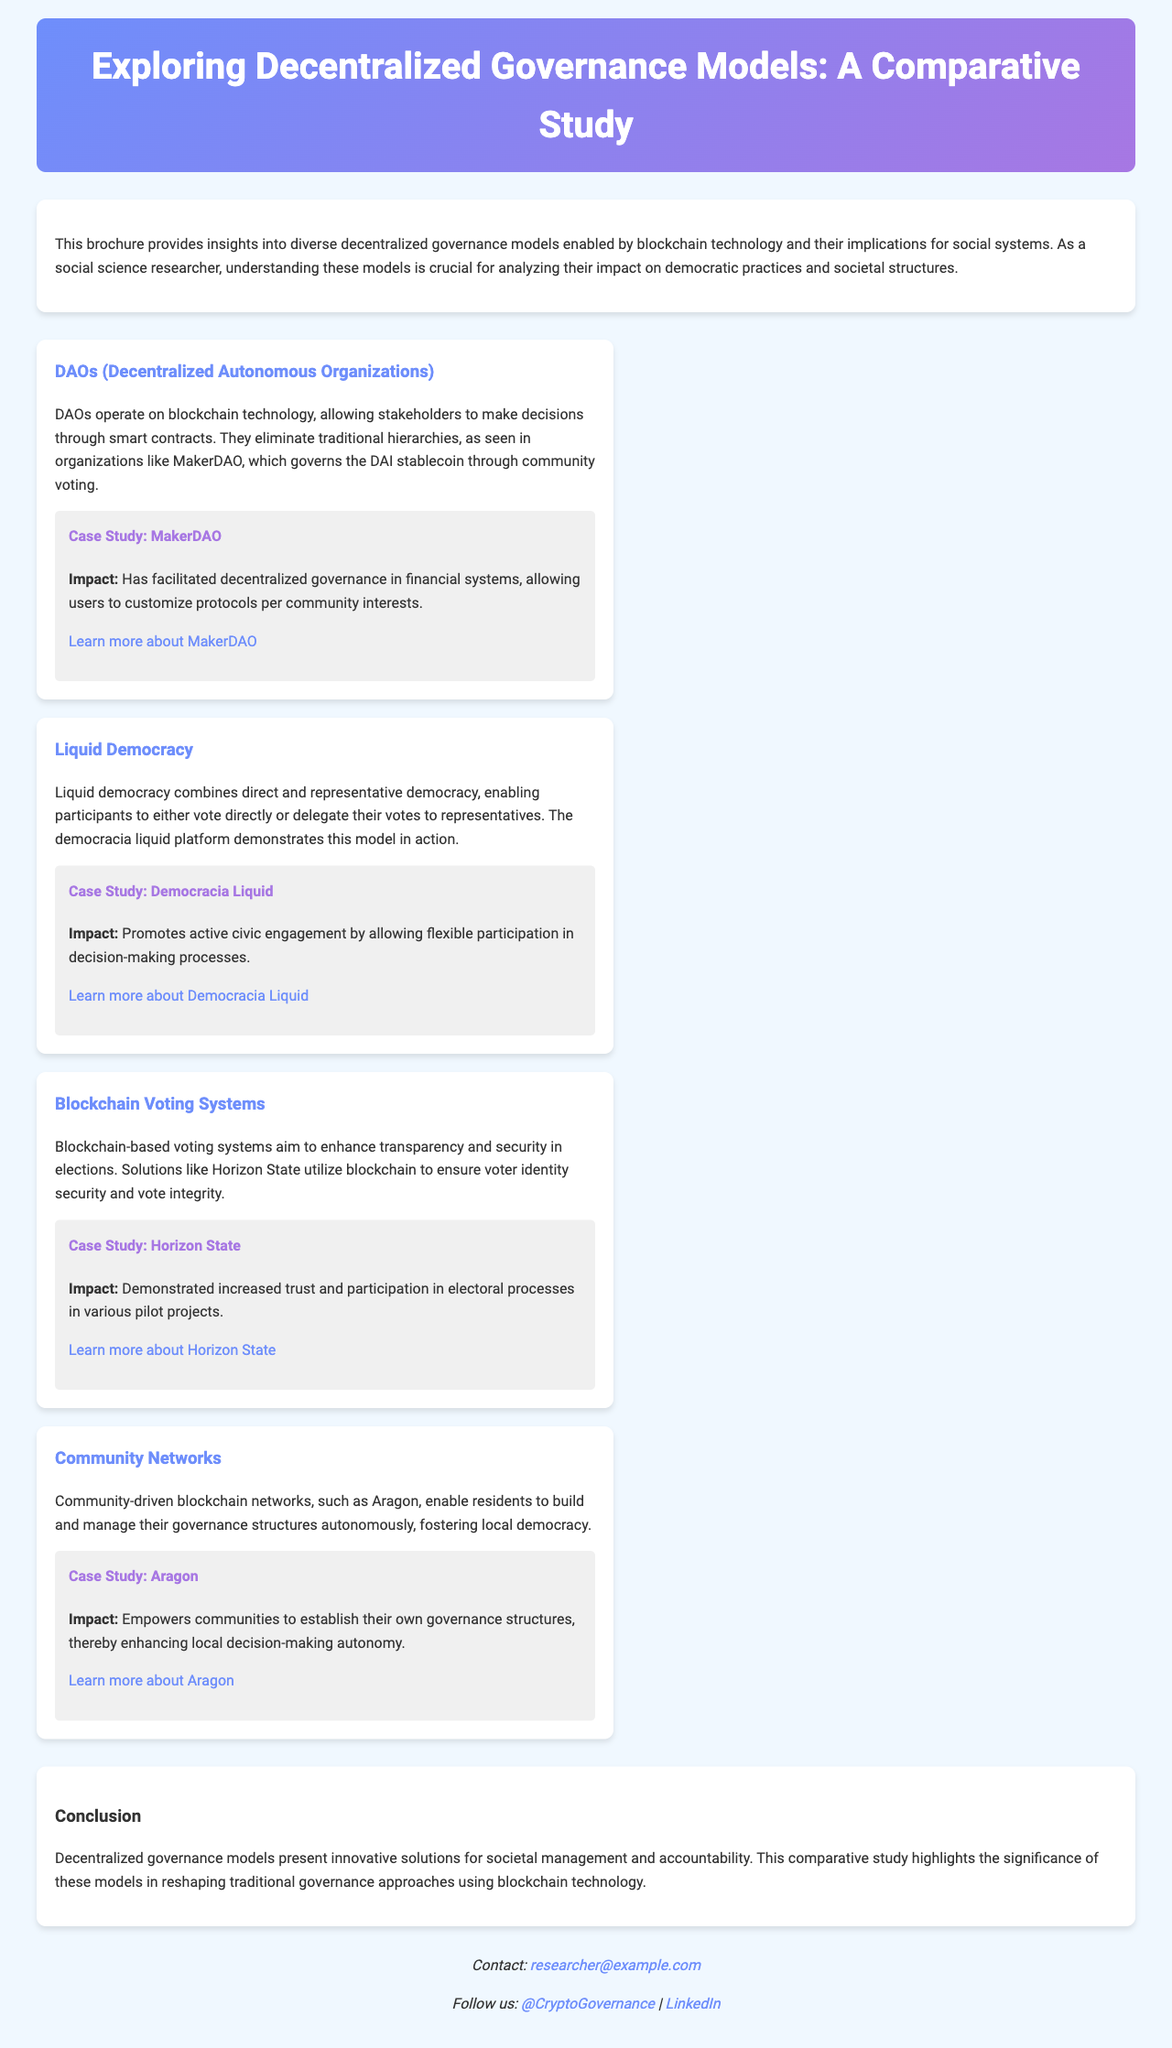What is the title of the study? The title clearly states the focus of the document, which is "Exploring Decentralized Governance Models: A Comparative Study."
Answer: Exploring Decentralized Governance Models: A Comparative Study What is a DAO? The brochure describes DAOs as organizations that operate on blockchain technology, facilitating decision-making through smart contracts.
Answer: Decentralized Autonomous Organizations What case study is featured for MakerDAO? The brochure specifically names MakerDAO as the case study related to DAOs.
Answer: MakerDAO What impact does the Democracia Liquid case study promote? The brochure states that Democracia Liquid promotes active civic engagement by allowing flexible participation in decision-making processes.
Answer: Active civic engagement Which model allows participants to either vote directly or delegate their votes? The brochure explains that Liquid Democracy combines direct and representative democracy, allowing this flexibility in voting.
Answer: Liquid Democracy What is the main purpose of blockchain voting systems? The brochure outlines that blockchain-based voting systems aim to enhance transparency and security in elections.
Answer: Enhance transparency and security What is the significance of decentralized governance models according to the conclusion? The conclusion highlights that these models present innovative solutions for societal management and accountability.
Answer: Innovative solutions for societal management Which platform is used in the community networks model mentioned? The text notes Aragon as an example of a community-driven blockchain network.
Answer: Aragon What is the email contact provided in the brochure? The contact information includes an email address for inquiries which is research@example.com.
Answer: researcher@example.com 